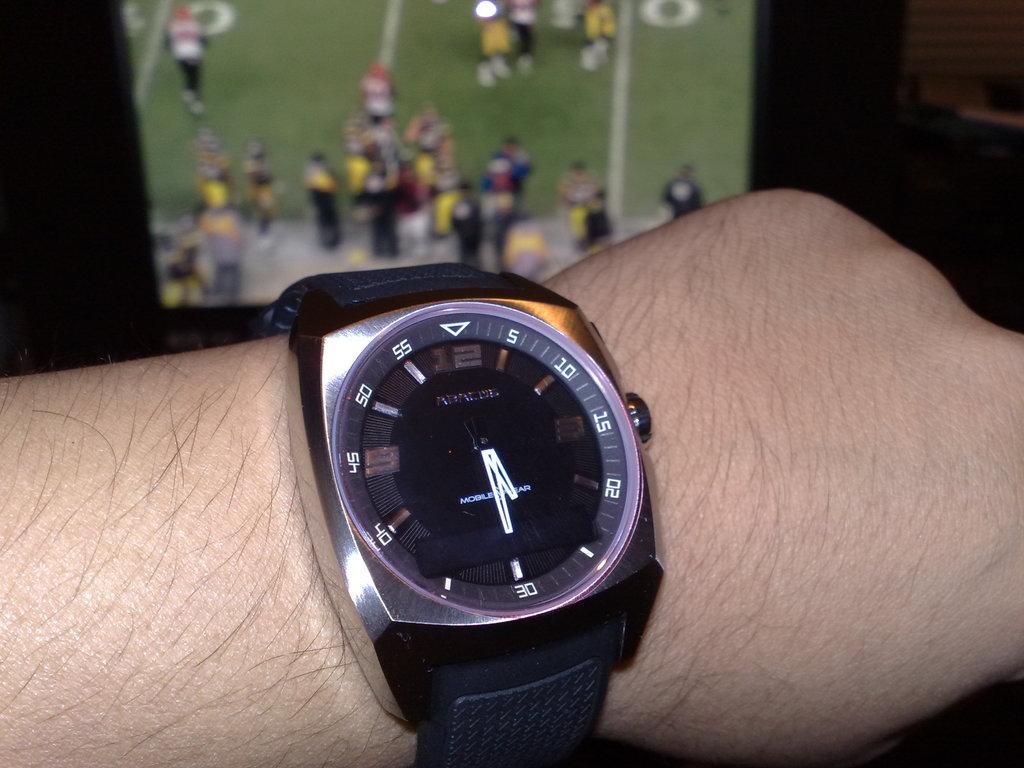What time is it?
Offer a very short reply. 5:30. What big numbers are at the top of the watch?
Your answer should be compact. 12. 